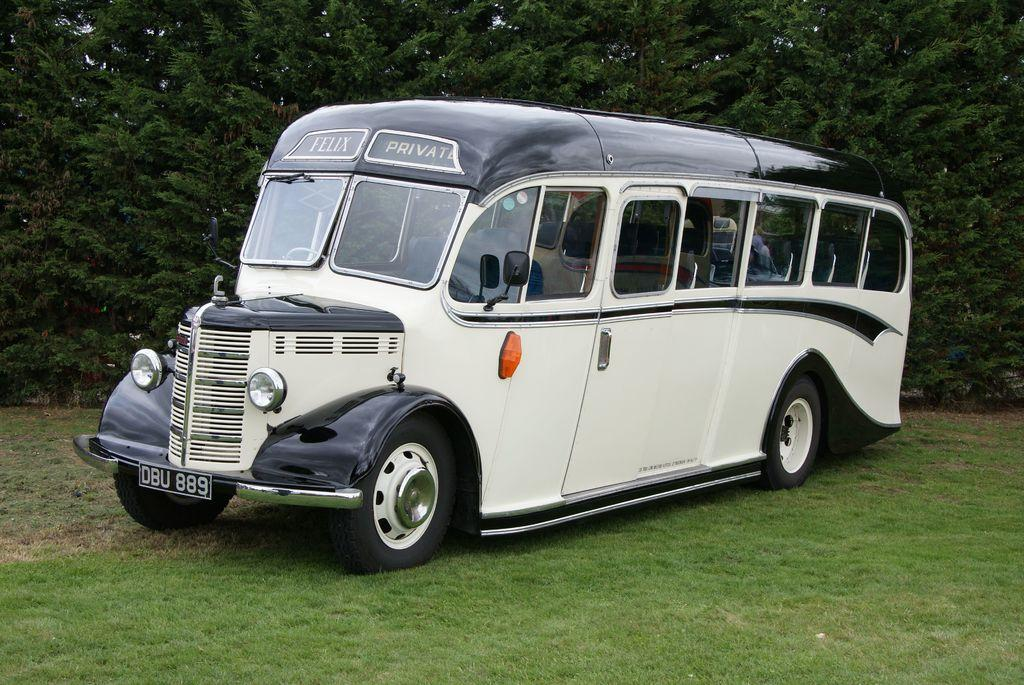<image>
Present a compact description of the photo's key features. a vehicle with the letters DBU on the front 